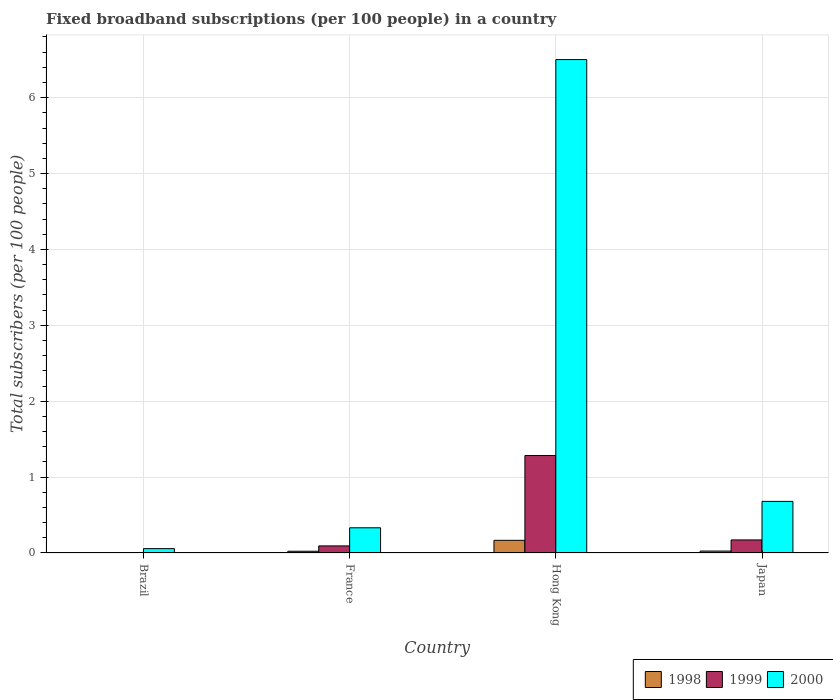Are the number of bars on each tick of the X-axis equal?
Ensure brevity in your answer.  Yes. How many bars are there on the 2nd tick from the left?
Offer a very short reply. 3. How many bars are there on the 1st tick from the right?
Offer a very short reply. 3. What is the label of the 2nd group of bars from the left?
Your answer should be very brief. France. In how many cases, is the number of bars for a given country not equal to the number of legend labels?
Give a very brief answer. 0. What is the number of broadband subscriptions in 2000 in France?
Give a very brief answer. 0.33. Across all countries, what is the maximum number of broadband subscriptions in 1999?
Your response must be concise. 1.28. Across all countries, what is the minimum number of broadband subscriptions in 1999?
Ensure brevity in your answer.  0. In which country was the number of broadband subscriptions in 2000 maximum?
Keep it short and to the point. Hong Kong. In which country was the number of broadband subscriptions in 2000 minimum?
Your answer should be very brief. Brazil. What is the total number of broadband subscriptions in 2000 in the graph?
Provide a short and direct response. 7.57. What is the difference between the number of broadband subscriptions in 1998 in France and that in Japan?
Give a very brief answer. -0. What is the difference between the number of broadband subscriptions in 1999 in Japan and the number of broadband subscriptions in 1998 in Brazil?
Ensure brevity in your answer.  0.17. What is the average number of broadband subscriptions in 1998 per country?
Your response must be concise. 0.05. What is the difference between the number of broadband subscriptions of/in 1999 and number of broadband subscriptions of/in 1998 in Hong Kong?
Ensure brevity in your answer.  1.12. In how many countries, is the number of broadband subscriptions in 1999 greater than 6.2?
Your response must be concise. 0. What is the ratio of the number of broadband subscriptions in 1998 in Brazil to that in Hong Kong?
Your response must be concise. 0. Is the number of broadband subscriptions in 1998 in Brazil less than that in France?
Give a very brief answer. Yes. Is the difference between the number of broadband subscriptions in 1999 in Brazil and France greater than the difference between the number of broadband subscriptions in 1998 in Brazil and France?
Your answer should be compact. No. What is the difference between the highest and the second highest number of broadband subscriptions in 1998?
Provide a succinct answer. 0.14. What is the difference between the highest and the lowest number of broadband subscriptions in 1999?
Offer a very short reply. 1.28. In how many countries, is the number of broadband subscriptions in 1999 greater than the average number of broadband subscriptions in 1999 taken over all countries?
Keep it short and to the point. 1. What does the 2nd bar from the left in Japan represents?
Ensure brevity in your answer.  1999. What does the 2nd bar from the right in Hong Kong represents?
Offer a very short reply. 1999. How many countries are there in the graph?
Make the answer very short. 4. What is the difference between two consecutive major ticks on the Y-axis?
Your answer should be compact. 1. Does the graph contain any zero values?
Provide a succinct answer. No. Where does the legend appear in the graph?
Offer a terse response. Bottom right. What is the title of the graph?
Keep it short and to the point. Fixed broadband subscriptions (per 100 people) in a country. What is the label or title of the Y-axis?
Provide a succinct answer. Total subscribers (per 100 people). What is the Total subscribers (per 100 people) of 1998 in Brazil?
Provide a succinct answer. 0. What is the Total subscribers (per 100 people) in 1999 in Brazil?
Your answer should be compact. 0. What is the Total subscribers (per 100 people) in 2000 in Brazil?
Keep it short and to the point. 0.06. What is the Total subscribers (per 100 people) in 1998 in France?
Make the answer very short. 0.02. What is the Total subscribers (per 100 people) in 1999 in France?
Ensure brevity in your answer.  0.09. What is the Total subscribers (per 100 people) in 2000 in France?
Your answer should be compact. 0.33. What is the Total subscribers (per 100 people) of 1998 in Hong Kong?
Your answer should be very brief. 0.17. What is the Total subscribers (per 100 people) of 1999 in Hong Kong?
Your answer should be very brief. 1.28. What is the Total subscribers (per 100 people) of 2000 in Hong Kong?
Your response must be concise. 6.5. What is the Total subscribers (per 100 people) in 1998 in Japan?
Provide a succinct answer. 0.03. What is the Total subscribers (per 100 people) in 1999 in Japan?
Offer a very short reply. 0.17. What is the Total subscribers (per 100 people) of 2000 in Japan?
Provide a short and direct response. 0.68. Across all countries, what is the maximum Total subscribers (per 100 people) of 1998?
Provide a short and direct response. 0.17. Across all countries, what is the maximum Total subscribers (per 100 people) of 1999?
Keep it short and to the point. 1.28. Across all countries, what is the maximum Total subscribers (per 100 people) in 2000?
Give a very brief answer. 6.5. Across all countries, what is the minimum Total subscribers (per 100 people) of 1998?
Make the answer very short. 0. Across all countries, what is the minimum Total subscribers (per 100 people) of 1999?
Your answer should be very brief. 0. Across all countries, what is the minimum Total subscribers (per 100 people) of 2000?
Your response must be concise. 0.06. What is the total Total subscribers (per 100 people) of 1998 in the graph?
Give a very brief answer. 0.22. What is the total Total subscribers (per 100 people) in 1999 in the graph?
Provide a short and direct response. 1.55. What is the total Total subscribers (per 100 people) in 2000 in the graph?
Provide a succinct answer. 7.57. What is the difference between the Total subscribers (per 100 people) in 1998 in Brazil and that in France?
Ensure brevity in your answer.  -0.02. What is the difference between the Total subscribers (per 100 people) of 1999 in Brazil and that in France?
Offer a very short reply. -0.09. What is the difference between the Total subscribers (per 100 people) of 2000 in Brazil and that in France?
Provide a short and direct response. -0.27. What is the difference between the Total subscribers (per 100 people) in 1998 in Brazil and that in Hong Kong?
Make the answer very short. -0.17. What is the difference between the Total subscribers (per 100 people) of 1999 in Brazil and that in Hong Kong?
Your answer should be compact. -1.28. What is the difference between the Total subscribers (per 100 people) in 2000 in Brazil and that in Hong Kong?
Ensure brevity in your answer.  -6.45. What is the difference between the Total subscribers (per 100 people) in 1998 in Brazil and that in Japan?
Provide a succinct answer. -0.03. What is the difference between the Total subscribers (per 100 people) of 1999 in Brazil and that in Japan?
Make the answer very short. -0.17. What is the difference between the Total subscribers (per 100 people) in 2000 in Brazil and that in Japan?
Your answer should be compact. -0.62. What is the difference between the Total subscribers (per 100 people) of 1998 in France and that in Hong Kong?
Your response must be concise. -0.14. What is the difference between the Total subscribers (per 100 people) in 1999 in France and that in Hong Kong?
Make the answer very short. -1.19. What is the difference between the Total subscribers (per 100 people) in 2000 in France and that in Hong Kong?
Offer a terse response. -6.17. What is the difference between the Total subscribers (per 100 people) of 1998 in France and that in Japan?
Make the answer very short. -0. What is the difference between the Total subscribers (per 100 people) of 1999 in France and that in Japan?
Make the answer very short. -0.08. What is the difference between the Total subscribers (per 100 people) in 2000 in France and that in Japan?
Provide a short and direct response. -0.35. What is the difference between the Total subscribers (per 100 people) of 1998 in Hong Kong and that in Japan?
Your answer should be very brief. 0.14. What is the difference between the Total subscribers (per 100 people) of 1999 in Hong Kong and that in Japan?
Provide a short and direct response. 1.11. What is the difference between the Total subscribers (per 100 people) in 2000 in Hong Kong and that in Japan?
Ensure brevity in your answer.  5.82. What is the difference between the Total subscribers (per 100 people) in 1998 in Brazil and the Total subscribers (per 100 people) in 1999 in France?
Keep it short and to the point. -0.09. What is the difference between the Total subscribers (per 100 people) of 1998 in Brazil and the Total subscribers (per 100 people) of 2000 in France?
Provide a short and direct response. -0.33. What is the difference between the Total subscribers (per 100 people) of 1999 in Brazil and the Total subscribers (per 100 people) of 2000 in France?
Ensure brevity in your answer.  -0.33. What is the difference between the Total subscribers (per 100 people) of 1998 in Brazil and the Total subscribers (per 100 people) of 1999 in Hong Kong?
Provide a succinct answer. -1.28. What is the difference between the Total subscribers (per 100 people) of 1998 in Brazil and the Total subscribers (per 100 people) of 2000 in Hong Kong?
Offer a very short reply. -6.5. What is the difference between the Total subscribers (per 100 people) of 1999 in Brazil and the Total subscribers (per 100 people) of 2000 in Hong Kong?
Keep it short and to the point. -6.5. What is the difference between the Total subscribers (per 100 people) of 1998 in Brazil and the Total subscribers (per 100 people) of 1999 in Japan?
Your response must be concise. -0.17. What is the difference between the Total subscribers (per 100 people) of 1998 in Brazil and the Total subscribers (per 100 people) of 2000 in Japan?
Provide a succinct answer. -0.68. What is the difference between the Total subscribers (per 100 people) in 1999 in Brazil and the Total subscribers (per 100 people) in 2000 in Japan?
Your answer should be compact. -0.68. What is the difference between the Total subscribers (per 100 people) in 1998 in France and the Total subscribers (per 100 people) in 1999 in Hong Kong?
Your response must be concise. -1.26. What is the difference between the Total subscribers (per 100 people) in 1998 in France and the Total subscribers (per 100 people) in 2000 in Hong Kong?
Provide a succinct answer. -6.48. What is the difference between the Total subscribers (per 100 people) of 1999 in France and the Total subscribers (per 100 people) of 2000 in Hong Kong?
Offer a very short reply. -6.41. What is the difference between the Total subscribers (per 100 people) in 1998 in France and the Total subscribers (per 100 people) in 1999 in Japan?
Ensure brevity in your answer.  -0.15. What is the difference between the Total subscribers (per 100 people) in 1998 in France and the Total subscribers (per 100 people) in 2000 in Japan?
Your answer should be very brief. -0.66. What is the difference between the Total subscribers (per 100 people) of 1999 in France and the Total subscribers (per 100 people) of 2000 in Japan?
Make the answer very short. -0.59. What is the difference between the Total subscribers (per 100 people) in 1998 in Hong Kong and the Total subscribers (per 100 people) in 1999 in Japan?
Keep it short and to the point. -0.01. What is the difference between the Total subscribers (per 100 people) in 1998 in Hong Kong and the Total subscribers (per 100 people) in 2000 in Japan?
Ensure brevity in your answer.  -0.51. What is the difference between the Total subscribers (per 100 people) of 1999 in Hong Kong and the Total subscribers (per 100 people) of 2000 in Japan?
Provide a succinct answer. 0.6. What is the average Total subscribers (per 100 people) in 1998 per country?
Offer a terse response. 0.05. What is the average Total subscribers (per 100 people) in 1999 per country?
Provide a short and direct response. 0.39. What is the average Total subscribers (per 100 people) of 2000 per country?
Provide a succinct answer. 1.89. What is the difference between the Total subscribers (per 100 people) in 1998 and Total subscribers (per 100 people) in 1999 in Brazil?
Provide a short and direct response. -0. What is the difference between the Total subscribers (per 100 people) of 1998 and Total subscribers (per 100 people) of 2000 in Brazil?
Provide a succinct answer. -0.06. What is the difference between the Total subscribers (per 100 people) of 1999 and Total subscribers (per 100 people) of 2000 in Brazil?
Make the answer very short. -0.05. What is the difference between the Total subscribers (per 100 people) in 1998 and Total subscribers (per 100 people) in 1999 in France?
Your answer should be compact. -0.07. What is the difference between the Total subscribers (per 100 people) in 1998 and Total subscribers (per 100 people) in 2000 in France?
Offer a very short reply. -0.31. What is the difference between the Total subscribers (per 100 people) in 1999 and Total subscribers (per 100 people) in 2000 in France?
Make the answer very short. -0.24. What is the difference between the Total subscribers (per 100 people) in 1998 and Total subscribers (per 100 people) in 1999 in Hong Kong?
Your response must be concise. -1.12. What is the difference between the Total subscribers (per 100 people) in 1998 and Total subscribers (per 100 people) in 2000 in Hong Kong?
Ensure brevity in your answer.  -6.34. What is the difference between the Total subscribers (per 100 people) of 1999 and Total subscribers (per 100 people) of 2000 in Hong Kong?
Your response must be concise. -5.22. What is the difference between the Total subscribers (per 100 people) in 1998 and Total subscribers (per 100 people) in 1999 in Japan?
Give a very brief answer. -0.15. What is the difference between the Total subscribers (per 100 people) in 1998 and Total subscribers (per 100 people) in 2000 in Japan?
Provide a succinct answer. -0.65. What is the difference between the Total subscribers (per 100 people) of 1999 and Total subscribers (per 100 people) of 2000 in Japan?
Your answer should be very brief. -0.51. What is the ratio of the Total subscribers (per 100 people) of 1998 in Brazil to that in France?
Keep it short and to the point. 0.03. What is the ratio of the Total subscribers (per 100 people) in 1999 in Brazil to that in France?
Provide a succinct answer. 0.04. What is the ratio of the Total subscribers (per 100 people) in 2000 in Brazil to that in France?
Keep it short and to the point. 0.17. What is the ratio of the Total subscribers (per 100 people) in 1998 in Brazil to that in Hong Kong?
Your answer should be compact. 0. What is the ratio of the Total subscribers (per 100 people) of 1999 in Brazil to that in Hong Kong?
Provide a succinct answer. 0. What is the ratio of the Total subscribers (per 100 people) in 2000 in Brazil to that in Hong Kong?
Make the answer very short. 0.01. What is the ratio of the Total subscribers (per 100 people) in 1998 in Brazil to that in Japan?
Offer a terse response. 0.02. What is the ratio of the Total subscribers (per 100 people) of 1999 in Brazil to that in Japan?
Provide a short and direct response. 0.02. What is the ratio of the Total subscribers (per 100 people) in 2000 in Brazil to that in Japan?
Your answer should be compact. 0.08. What is the ratio of the Total subscribers (per 100 people) in 1998 in France to that in Hong Kong?
Your answer should be compact. 0.14. What is the ratio of the Total subscribers (per 100 people) of 1999 in France to that in Hong Kong?
Provide a short and direct response. 0.07. What is the ratio of the Total subscribers (per 100 people) of 2000 in France to that in Hong Kong?
Your answer should be very brief. 0.05. What is the ratio of the Total subscribers (per 100 people) in 1998 in France to that in Japan?
Offer a very short reply. 0.9. What is the ratio of the Total subscribers (per 100 people) in 1999 in France to that in Japan?
Offer a terse response. 0.54. What is the ratio of the Total subscribers (per 100 people) in 2000 in France to that in Japan?
Ensure brevity in your answer.  0.49. What is the ratio of the Total subscribers (per 100 people) in 1998 in Hong Kong to that in Japan?
Offer a terse response. 6.53. What is the ratio of the Total subscribers (per 100 people) in 1999 in Hong Kong to that in Japan?
Give a very brief answer. 7.46. What is the ratio of the Total subscribers (per 100 people) in 2000 in Hong Kong to that in Japan?
Provide a succinct answer. 9.56. What is the difference between the highest and the second highest Total subscribers (per 100 people) in 1998?
Keep it short and to the point. 0.14. What is the difference between the highest and the second highest Total subscribers (per 100 people) in 1999?
Provide a succinct answer. 1.11. What is the difference between the highest and the second highest Total subscribers (per 100 people) in 2000?
Your answer should be compact. 5.82. What is the difference between the highest and the lowest Total subscribers (per 100 people) in 1998?
Give a very brief answer. 0.17. What is the difference between the highest and the lowest Total subscribers (per 100 people) in 1999?
Provide a short and direct response. 1.28. What is the difference between the highest and the lowest Total subscribers (per 100 people) in 2000?
Keep it short and to the point. 6.45. 